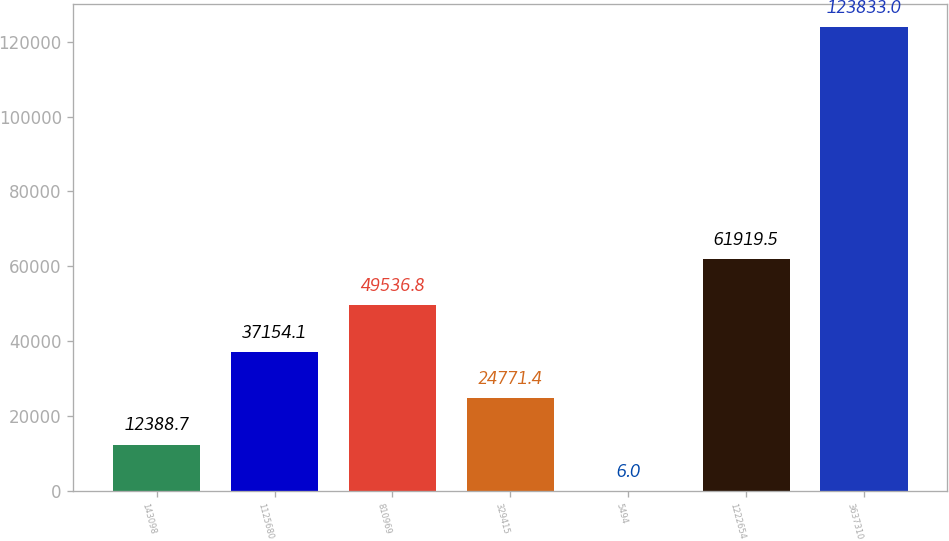Convert chart. <chart><loc_0><loc_0><loc_500><loc_500><bar_chart><fcel>143098<fcel>1125680<fcel>810969<fcel>329415<fcel>5494<fcel>1222654<fcel>3637310<nl><fcel>12388.7<fcel>37154.1<fcel>49536.8<fcel>24771.4<fcel>6<fcel>61919.5<fcel>123833<nl></chart> 